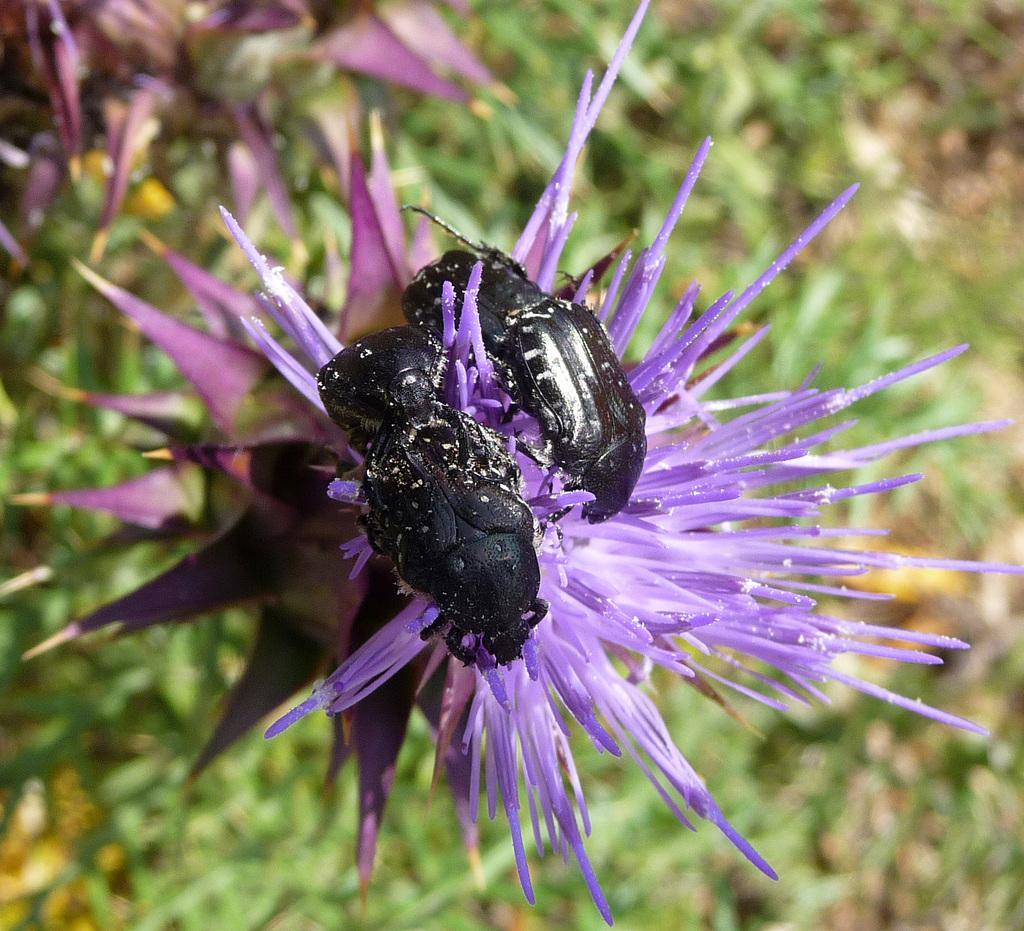Describe this image in one or two sentences. In the image there are two bugs standing on the purple flower, there are many plants on the ground. 